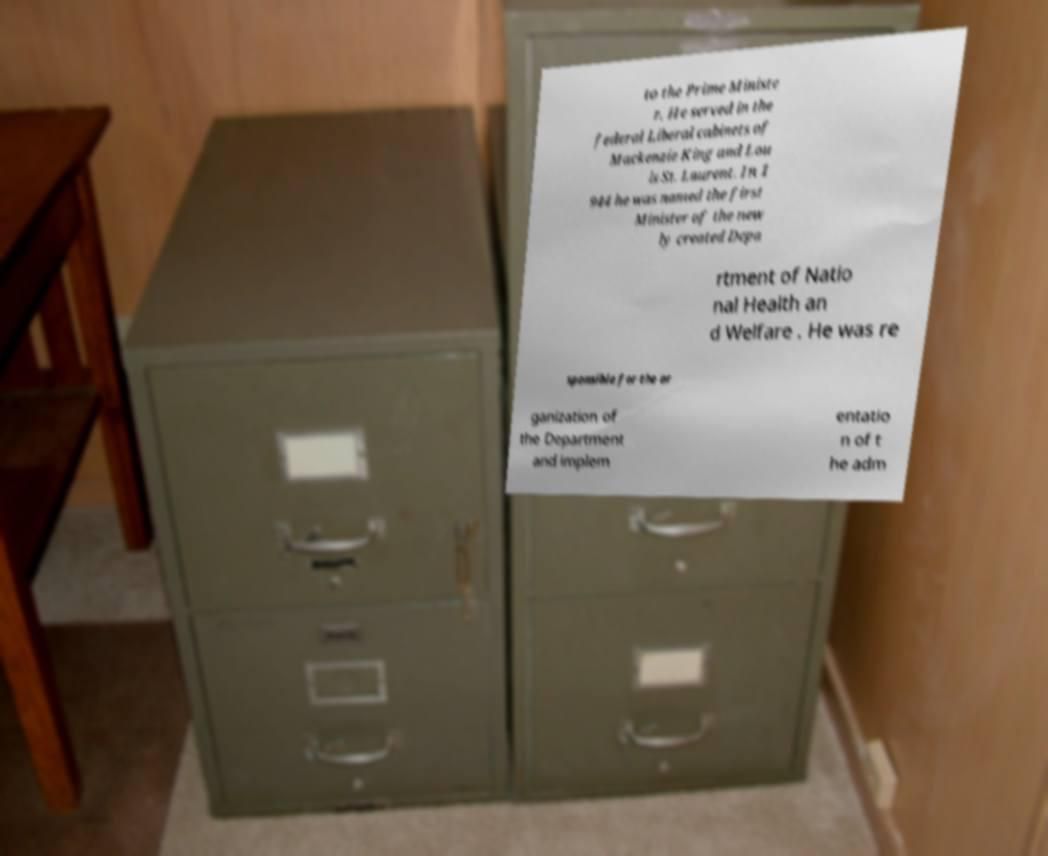Please read and relay the text visible in this image. What does it say? to the Prime Ministe r. He served in the federal Liberal cabinets of Mackenzie King and Lou is St. Laurent. In 1 944 he was named the first Minister of the new ly created Depa rtment of Natio nal Health an d Welfare . He was re sponsible for the or ganization of the Department and implem entatio n of t he adm 